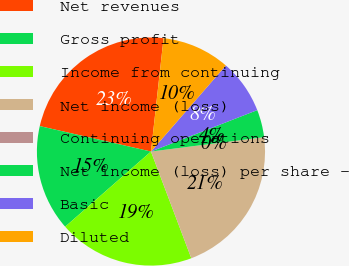<chart> <loc_0><loc_0><loc_500><loc_500><pie_chart><fcel>Net revenues<fcel>Gross profit<fcel>Income from continuing<fcel>Net income (loss)<fcel>Continuing operations<fcel>Net income (loss) per share -<fcel>Basic<fcel>Diluted<nl><fcel>23.18%<fcel>15.03%<fcel>19.3%<fcel>21.24%<fcel>0.02%<fcel>3.9%<fcel>7.69%<fcel>9.63%<nl></chart> 